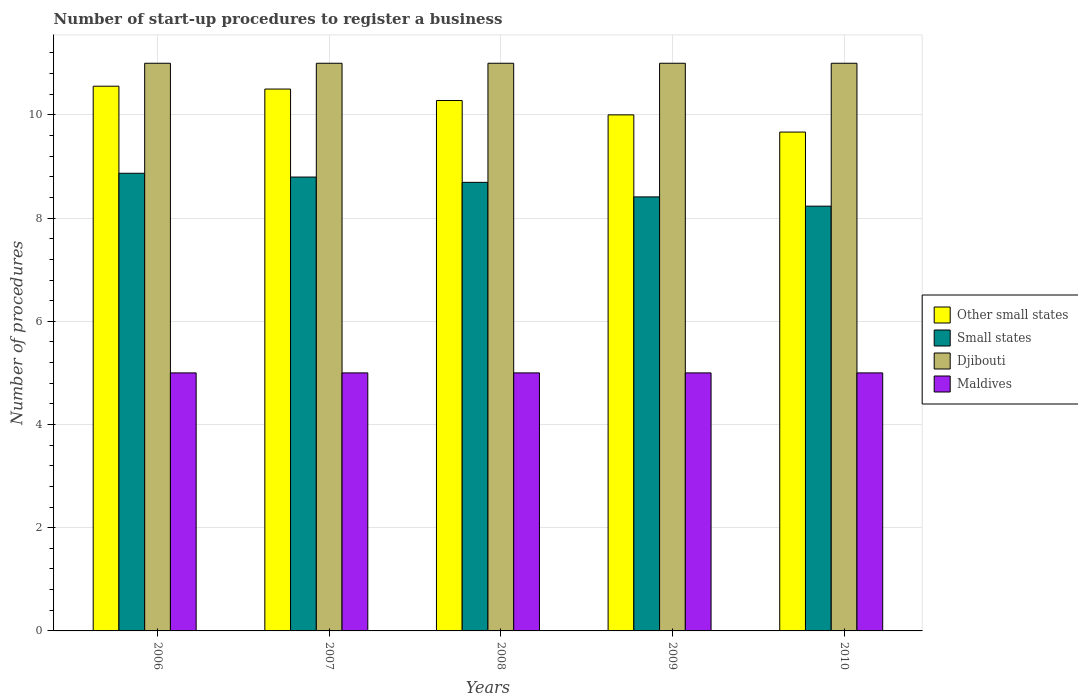How many groups of bars are there?
Provide a short and direct response. 5. How many bars are there on the 5th tick from the right?
Offer a terse response. 4. What is the label of the 5th group of bars from the left?
Give a very brief answer. 2010. Across all years, what is the maximum number of procedures required to register a business in Maldives?
Offer a very short reply. 5. In which year was the number of procedures required to register a business in Djibouti maximum?
Make the answer very short. 2006. In which year was the number of procedures required to register a business in Other small states minimum?
Your answer should be compact. 2010. What is the total number of procedures required to register a business in Small states in the graph?
Provide a succinct answer. 43. What is the difference between the number of procedures required to register a business in Other small states in 2007 and the number of procedures required to register a business in Djibouti in 2006?
Your answer should be very brief. -0.5. In the year 2006, what is the difference between the number of procedures required to register a business in Maldives and number of procedures required to register a business in Small states?
Make the answer very short. -3.87. In how many years, is the number of procedures required to register a business in Maldives greater than the average number of procedures required to register a business in Maldives taken over all years?
Your answer should be compact. 0. Is the sum of the number of procedures required to register a business in Small states in 2007 and 2009 greater than the maximum number of procedures required to register a business in Maldives across all years?
Provide a short and direct response. Yes. Is it the case that in every year, the sum of the number of procedures required to register a business in Small states and number of procedures required to register a business in Djibouti is greater than the sum of number of procedures required to register a business in Other small states and number of procedures required to register a business in Maldives?
Ensure brevity in your answer.  Yes. What does the 2nd bar from the left in 2010 represents?
Give a very brief answer. Small states. What does the 2nd bar from the right in 2008 represents?
Offer a very short reply. Djibouti. Is it the case that in every year, the sum of the number of procedures required to register a business in Maldives and number of procedures required to register a business in Other small states is greater than the number of procedures required to register a business in Small states?
Provide a short and direct response. Yes. How many bars are there?
Offer a terse response. 20. Does the graph contain any zero values?
Offer a terse response. No. Does the graph contain grids?
Offer a terse response. Yes. Where does the legend appear in the graph?
Keep it short and to the point. Center right. How many legend labels are there?
Your response must be concise. 4. What is the title of the graph?
Make the answer very short. Number of start-up procedures to register a business. Does "Niger" appear as one of the legend labels in the graph?
Offer a very short reply. No. What is the label or title of the X-axis?
Provide a short and direct response. Years. What is the label or title of the Y-axis?
Give a very brief answer. Number of procedures. What is the Number of procedures in Other small states in 2006?
Your answer should be compact. 10.56. What is the Number of procedures of Small states in 2006?
Provide a short and direct response. 8.87. What is the Number of procedures in Djibouti in 2006?
Make the answer very short. 11. What is the Number of procedures of Other small states in 2007?
Your answer should be very brief. 10.5. What is the Number of procedures of Small states in 2007?
Ensure brevity in your answer.  8.79. What is the Number of procedures in Djibouti in 2007?
Offer a very short reply. 11. What is the Number of procedures in Maldives in 2007?
Provide a succinct answer. 5. What is the Number of procedures in Other small states in 2008?
Offer a terse response. 10.28. What is the Number of procedures in Small states in 2008?
Provide a short and direct response. 8.69. What is the Number of procedures in Other small states in 2009?
Your response must be concise. 10. What is the Number of procedures of Small states in 2009?
Offer a terse response. 8.41. What is the Number of procedures of Maldives in 2009?
Your answer should be compact. 5. What is the Number of procedures of Other small states in 2010?
Make the answer very short. 9.67. What is the Number of procedures of Small states in 2010?
Provide a short and direct response. 8.23. What is the Number of procedures in Djibouti in 2010?
Provide a short and direct response. 11. What is the Number of procedures of Maldives in 2010?
Keep it short and to the point. 5. Across all years, what is the maximum Number of procedures in Other small states?
Your answer should be very brief. 10.56. Across all years, what is the maximum Number of procedures in Small states?
Your response must be concise. 8.87. Across all years, what is the maximum Number of procedures of Djibouti?
Your answer should be compact. 11. Across all years, what is the maximum Number of procedures in Maldives?
Ensure brevity in your answer.  5. Across all years, what is the minimum Number of procedures of Other small states?
Offer a very short reply. 9.67. Across all years, what is the minimum Number of procedures of Small states?
Provide a succinct answer. 8.23. Across all years, what is the minimum Number of procedures of Djibouti?
Offer a very short reply. 11. What is the total Number of procedures of Small states in the graph?
Your answer should be compact. 43. What is the total Number of procedures in Djibouti in the graph?
Your answer should be compact. 55. What is the total Number of procedures in Maldives in the graph?
Offer a very short reply. 25. What is the difference between the Number of procedures in Other small states in 2006 and that in 2007?
Offer a terse response. 0.06. What is the difference between the Number of procedures in Small states in 2006 and that in 2007?
Ensure brevity in your answer.  0.07. What is the difference between the Number of procedures in Other small states in 2006 and that in 2008?
Offer a terse response. 0.28. What is the difference between the Number of procedures in Small states in 2006 and that in 2008?
Provide a succinct answer. 0.18. What is the difference between the Number of procedures in Other small states in 2006 and that in 2009?
Your response must be concise. 0.56. What is the difference between the Number of procedures in Small states in 2006 and that in 2009?
Offer a very short reply. 0.46. What is the difference between the Number of procedures in Djibouti in 2006 and that in 2009?
Ensure brevity in your answer.  0. What is the difference between the Number of procedures of Small states in 2006 and that in 2010?
Keep it short and to the point. 0.64. What is the difference between the Number of procedures of Djibouti in 2006 and that in 2010?
Keep it short and to the point. 0. What is the difference between the Number of procedures in Other small states in 2007 and that in 2008?
Give a very brief answer. 0.22. What is the difference between the Number of procedures of Small states in 2007 and that in 2008?
Provide a succinct answer. 0.1. What is the difference between the Number of procedures of Djibouti in 2007 and that in 2008?
Offer a very short reply. 0. What is the difference between the Number of procedures in Other small states in 2007 and that in 2009?
Provide a succinct answer. 0.5. What is the difference between the Number of procedures of Small states in 2007 and that in 2009?
Offer a terse response. 0.38. What is the difference between the Number of procedures in Maldives in 2007 and that in 2009?
Provide a succinct answer. 0. What is the difference between the Number of procedures in Other small states in 2007 and that in 2010?
Offer a very short reply. 0.83. What is the difference between the Number of procedures in Small states in 2007 and that in 2010?
Your answer should be compact. 0.56. What is the difference between the Number of procedures in Djibouti in 2007 and that in 2010?
Keep it short and to the point. 0. What is the difference between the Number of procedures of Other small states in 2008 and that in 2009?
Your answer should be very brief. 0.28. What is the difference between the Number of procedures in Small states in 2008 and that in 2009?
Your answer should be very brief. 0.28. What is the difference between the Number of procedures in Other small states in 2008 and that in 2010?
Offer a very short reply. 0.61. What is the difference between the Number of procedures in Small states in 2008 and that in 2010?
Provide a short and direct response. 0.46. What is the difference between the Number of procedures of Djibouti in 2008 and that in 2010?
Your answer should be very brief. 0. What is the difference between the Number of procedures in Other small states in 2009 and that in 2010?
Give a very brief answer. 0.33. What is the difference between the Number of procedures of Small states in 2009 and that in 2010?
Your answer should be very brief. 0.18. What is the difference between the Number of procedures in Other small states in 2006 and the Number of procedures in Small states in 2007?
Your response must be concise. 1.76. What is the difference between the Number of procedures in Other small states in 2006 and the Number of procedures in Djibouti in 2007?
Offer a very short reply. -0.44. What is the difference between the Number of procedures of Other small states in 2006 and the Number of procedures of Maldives in 2007?
Your response must be concise. 5.56. What is the difference between the Number of procedures in Small states in 2006 and the Number of procedures in Djibouti in 2007?
Your response must be concise. -2.13. What is the difference between the Number of procedures in Small states in 2006 and the Number of procedures in Maldives in 2007?
Make the answer very short. 3.87. What is the difference between the Number of procedures of Other small states in 2006 and the Number of procedures of Small states in 2008?
Ensure brevity in your answer.  1.86. What is the difference between the Number of procedures of Other small states in 2006 and the Number of procedures of Djibouti in 2008?
Your answer should be compact. -0.44. What is the difference between the Number of procedures of Other small states in 2006 and the Number of procedures of Maldives in 2008?
Provide a succinct answer. 5.56. What is the difference between the Number of procedures in Small states in 2006 and the Number of procedures in Djibouti in 2008?
Provide a succinct answer. -2.13. What is the difference between the Number of procedures in Small states in 2006 and the Number of procedures in Maldives in 2008?
Give a very brief answer. 3.87. What is the difference between the Number of procedures of Djibouti in 2006 and the Number of procedures of Maldives in 2008?
Your answer should be very brief. 6. What is the difference between the Number of procedures of Other small states in 2006 and the Number of procedures of Small states in 2009?
Offer a very short reply. 2.15. What is the difference between the Number of procedures of Other small states in 2006 and the Number of procedures of Djibouti in 2009?
Make the answer very short. -0.44. What is the difference between the Number of procedures in Other small states in 2006 and the Number of procedures in Maldives in 2009?
Offer a very short reply. 5.56. What is the difference between the Number of procedures in Small states in 2006 and the Number of procedures in Djibouti in 2009?
Offer a very short reply. -2.13. What is the difference between the Number of procedures of Small states in 2006 and the Number of procedures of Maldives in 2009?
Give a very brief answer. 3.87. What is the difference between the Number of procedures in Djibouti in 2006 and the Number of procedures in Maldives in 2009?
Provide a short and direct response. 6. What is the difference between the Number of procedures in Other small states in 2006 and the Number of procedures in Small states in 2010?
Give a very brief answer. 2.32. What is the difference between the Number of procedures in Other small states in 2006 and the Number of procedures in Djibouti in 2010?
Offer a terse response. -0.44. What is the difference between the Number of procedures in Other small states in 2006 and the Number of procedures in Maldives in 2010?
Keep it short and to the point. 5.56. What is the difference between the Number of procedures of Small states in 2006 and the Number of procedures of Djibouti in 2010?
Make the answer very short. -2.13. What is the difference between the Number of procedures of Small states in 2006 and the Number of procedures of Maldives in 2010?
Provide a succinct answer. 3.87. What is the difference between the Number of procedures of Other small states in 2007 and the Number of procedures of Small states in 2008?
Your answer should be very brief. 1.81. What is the difference between the Number of procedures in Other small states in 2007 and the Number of procedures in Maldives in 2008?
Your answer should be compact. 5.5. What is the difference between the Number of procedures of Small states in 2007 and the Number of procedures of Djibouti in 2008?
Your answer should be very brief. -2.21. What is the difference between the Number of procedures in Small states in 2007 and the Number of procedures in Maldives in 2008?
Your answer should be compact. 3.79. What is the difference between the Number of procedures in Djibouti in 2007 and the Number of procedures in Maldives in 2008?
Provide a short and direct response. 6. What is the difference between the Number of procedures in Other small states in 2007 and the Number of procedures in Small states in 2009?
Your response must be concise. 2.09. What is the difference between the Number of procedures in Other small states in 2007 and the Number of procedures in Djibouti in 2009?
Offer a terse response. -0.5. What is the difference between the Number of procedures in Small states in 2007 and the Number of procedures in Djibouti in 2009?
Give a very brief answer. -2.21. What is the difference between the Number of procedures of Small states in 2007 and the Number of procedures of Maldives in 2009?
Your response must be concise. 3.79. What is the difference between the Number of procedures in Other small states in 2007 and the Number of procedures in Small states in 2010?
Provide a short and direct response. 2.27. What is the difference between the Number of procedures of Small states in 2007 and the Number of procedures of Djibouti in 2010?
Your response must be concise. -2.21. What is the difference between the Number of procedures in Small states in 2007 and the Number of procedures in Maldives in 2010?
Your answer should be compact. 3.79. What is the difference between the Number of procedures in Djibouti in 2007 and the Number of procedures in Maldives in 2010?
Your answer should be compact. 6. What is the difference between the Number of procedures in Other small states in 2008 and the Number of procedures in Small states in 2009?
Ensure brevity in your answer.  1.87. What is the difference between the Number of procedures in Other small states in 2008 and the Number of procedures in Djibouti in 2009?
Your answer should be very brief. -0.72. What is the difference between the Number of procedures in Other small states in 2008 and the Number of procedures in Maldives in 2009?
Make the answer very short. 5.28. What is the difference between the Number of procedures in Small states in 2008 and the Number of procedures in Djibouti in 2009?
Give a very brief answer. -2.31. What is the difference between the Number of procedures in Small states in 2008 and the Number of procedures in Maldives in 2009?
Give a very brief answer. 3.69. What is the difference between the Number of procedures in Other small states in 2008 and the Number of procedures in Small states in 2010?
Your answer should be compact. 2.05. What is the difference between the Number of procedures of Other small states in 2008 and the Number of procedures of Djibouti in 2010?
Provide a succinct answer. -0.72. What is the difference between the Number of procedures in Other small states in 2008 and the Number of procedures in Maldives in 2010?
Your response must be concise. 5.28. What is the difference between the Number of procedures in Small states in 2008 and the Number of procedures in Djibouti in 2010?
Provide a short and direct response. -2.31. What is the difference between the Number of procedures in Small states in 2008 and the Number of procedures in Maldives in 2010?
Offer a terse response. 3.69. What is the difference between the Number of procedures in Djibouti in 2008 and the Number of procedures in Maldives in 2010?
Your answer should be compact. 6. What is the difference between the Number of procedures of Other small states in 2009 and the Number of procedures of Small states in 2010?
Your answer should be compact. 1.77. What is the difference between the Number of procedures in Other small states in 2009 and the Number of procedures in Djibouti in 2010?
Your answer should be very brief. -1. What is the difference between the Number of procedures of Small states in 2009 and the Number of procedures of Djibouti in 2010?
Provide a succinct answer. -2.59. What is the difference between the Number of procedures of Small states in 2009 and the Number of procedures of Maldives in 2010?
Provide a short and direct response. 3.41. What is the average Number of procedures in Small states per year?
Your answer should be compact. 8.6. What is the average Number of procedures of Djibouti per year?
Your answer should be very brief. 11. In the year 2006, what is the difference between the Number of procedures in Other small states and Number of procedures in Small states?
Keep it short and to the point. 1.69. In the year 2006, what is the difference between the Number of procedures of Other small states and Number of procedures of Djibouti?
Provide a short and direct response. -0.44. In the year 2006, what is the difference between the Number of procedures in Other small states and Number of procedures in Maldives?
Offer a very short reply. 5.56. In the year 2006, what is the difference between the Number of procedures of Small states and Number of procedures of Djibouti?
Offer a very short reply. -2.13. In the year 2006, what is the difference between the Number of procedures in Small states and Number of procedures in Maldives?
Keep it short and to the point. 3.87. In the year 2006, what is the difference between the Number of procedures in Djibouti and Number of procedures in Maldives?
Your answer should be very brief. 6. In the year 2007, what is the difference between the Number of procedures in Other small states and Number of procedures in Small states?
Provide a succinct answer. 1.71. In the year 2007, what is the difference between the Number of procedures in Other small states and Number of procedures in Djibouti?
Your answer should be very brief. -0.5. In the year 2007, what is the difference between the Number of procedures of Small states and Number of procedures of Djibouti?
Provide a succinct answer. -2.21. In the year 2007, what is the difference between the Number of procedures of Small states and Number of procedures of Maldives?
Give a very brief answer. 3.79. In the year 2008, what is the difference between the Number of procedures in Other small states and Number of procedures in Small states?
Give a very brief answer. 1.59. In the year 2008, what is the difference between the Number of procedures in Other small states and Number of procedures in Djibouti?
Keep it short and to the point. -0.72. In the year 2008, what is the difference between the Number of procedures of Other small states and Number of procedures of Maldives?
Offer a terse response. 5.28. In the year 2008, what is the difference between the Number of procedures in Small states and Number of procedures in Djibouti?
Provide a short and direct response. -2.31. In the year 2008, what is the difference between the Number of procedures of Small states and Number of procedures of Maldives?
Your response must be concise. 3.69. In the year 2008, what is the difference between the Number of procedures in Djibouti and Number of procedures in Maldives?
Your answer should be very brief. 6. In the year 2009, what is the difference between the Number of procedures in Other small states and Number of procedures in Small states?
Offer a very short reply. 1.59. In the year 2009, what is the difference between the Number of procedures of Other small states and Number of procedures of Djibouti?
Ensure brevity in your answer.  -1. In the year 2009, what is the difference between the Number of procedures in Small states and Number of procedures in Djibouti?
Make the answer very short. -2.59. In the year 2009, what is the difference between the Number of procedures of Small states and Number of procedures of Maldives?
Give a very brief answer. 3.41. In the year 2010, what is the difference between the Number of procedures of Other small states and Number of procedures of Small states?
Your response must be concise. 1.44. In the year 2010, what is the difference between the Number of procedures of Other small states and Number of procedures of Djibouti?
Provide a short and direct response. -1.33. In the year 2010, what is the difference between the Number of procedures in Other small states and Number of procedures in Maldives?
Make the answer very short. 4.67. In the year 2010, what is the difference between the Number of procedures of Small states and Number of procedures of Djibouti?
Make the answer very short. -2.77. In the year 2010, what is the difference between the Number of procedures in Small states and Number of procedures in Maldives?
Your answer should be compact. 3.23. In the year 2010, what is the difference between the Number of procedures of Djibouti and Number of procedures of Maldives?
Provide a short and direct response. 6. What is the ratio of the Number of procedures in Other small states in 2006 to that in 2007?
Give a very brief answer. 1.01. What is the ratio of the Number of procedures in Small states in 2006 to that in 2007?
Ensure brevity in your answer.  1.01. What is the ratio of the Number of procedures of Maldives in 2006 to that in 2007?
Keep it short and to the point. 1. What is the ratio of the Number of procedures of Small states in 2006 to that in 2008?
Give a very brief answer. 1.02. What is the ratio of the Number of procedures of Djibouti in 2006 to that in 2008?
Offer a very short reply. 1. What is the ratio of the Number of procedures of Maldives in 2006 to that in 2008?
Your answer should be very brief. 1. What is the ratio of the Number of procedures in Other small states in 2006 to that in 2009?
Provide a succinct answer. 1.06. What is the ratio of the Number of procedures of Small states in 2006 to that in 2009?
Provide a succinct answer. 1.05. What is the ratio of the Number of procedures in Djibouti in 2006 to that in 2009?
Give a very brief answer. 1. What is the ratio of the Number of procedures in Maldives in 2006 to that in 2009?
Your answer should be very brief. 1. What is the ratio of the Number of procedures in Other small states in 2006 to that in 2010?
Your response must be concise. 1.09. What is the ratio of the Number of procedures in Small states in 2006 to that in 2010?
Offer a terse response. 1.08. What is the ratio of the Number of procedures in Other small states in 2007 to that in 2008?
Your response must be concise. 1.02. What is the ratio of the Number of procedures in Small states in 2007 to that in 2008?
Keep it short and to the point. 1.01. What is the ratio of the Number of procedures in Other small states in 2007 to that in 2009?
Make the answer very short. 1.05. What is the ratio of the Number of procedures in Small states in 2007 to that in 2009?
Provide a succinct answer. 1.05. What is the ratio of the Number of procedures of Maldives in 2007 to that in 2009?
Make the answer very short. 1. What is the ratio of the Number of procedures of Other small states in 2007 to that in 2010?
Your answer should be very brief. 1.09. What is the ratio of the Number of procedures of Small states in 2007 to that in 2010?
Give a very brief answer. 1.07. What is the ratio of the Number of procedures in Other small states in 2008 to that in 2009?
Provide a succinct answer. 1.03. What is the ratio of the Number of procedures in Small states in 2008 to that in 2009?
Provide a short and direct response. 1.03. What is the ratio of the Number of procedures of Djibouti in 2008 to that in 2009?
Give a very brief answer. 1. What is the ratio of the Number of procedures of Other small states in 2008 to that in 2010?
Provide a short and direct response. 1.06. What is the ratio of the Number of procedures of Small states in 2008 to that in 2010?
Make the answer very short. 1.06. What is the ratio of the Number of procedures in Other small states in 2009 to that in 2010?
Offer a very short reply. 1.03. What is the ratio of the Number of procedures of Small states in 2009 to that in 2010?
Make the answer very short. 1.02. What is the ratio of the Number of procedures of Maldives in 2009 to that in 2010?
Provide a short and direct response. 1. What is the difference between the highest and the second highest Number of procedures of Other small states?
Keep it short and to the point. 0.06. What is the difference between the highest and the second highest Number of procedures in Small states?
Make the answer very short. 0.07. What is the difference between the highest and the second highest Number of procedures in Djibouti?
Make the answer very short. 0. What is the difference between the highest and the second highest Number of procedures of Maldives?
Offer a very short reply. 0. What is the difference between the highest and the lowest Number of procedures of Small states?
Your answer should be very brief. 0.64. What is the difference between the highest and the lowest Number of procedures of Maldives?
Your response must be concise. 0. 